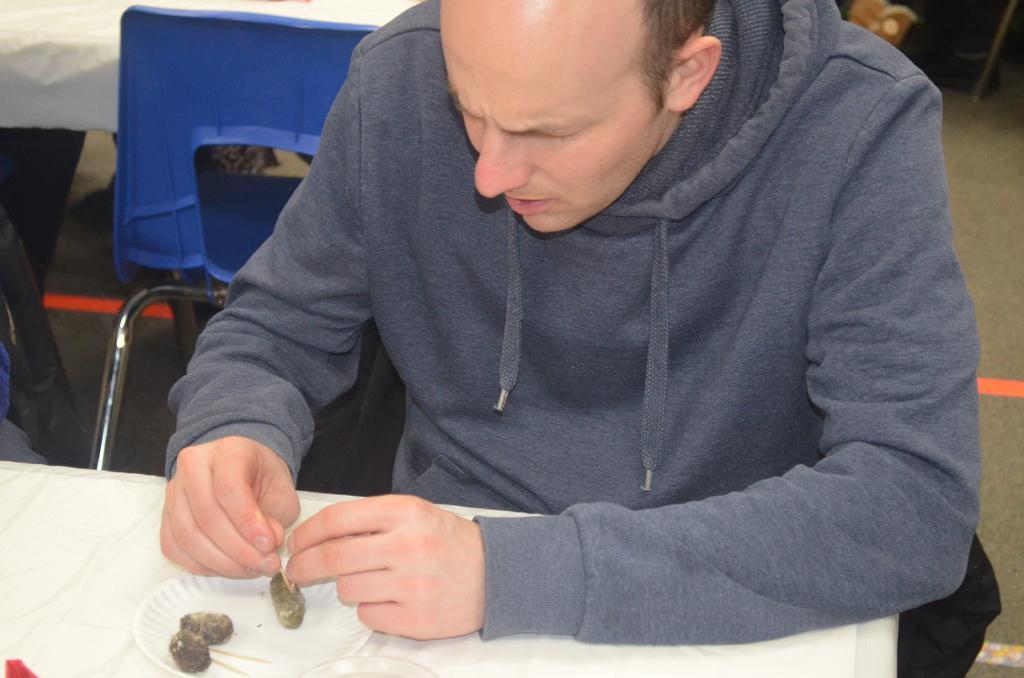How would you summarize this image in a sentence or two? In the picture there is a man sitting in front of a table,he is eating some food and there is a blue chair behind the man. 